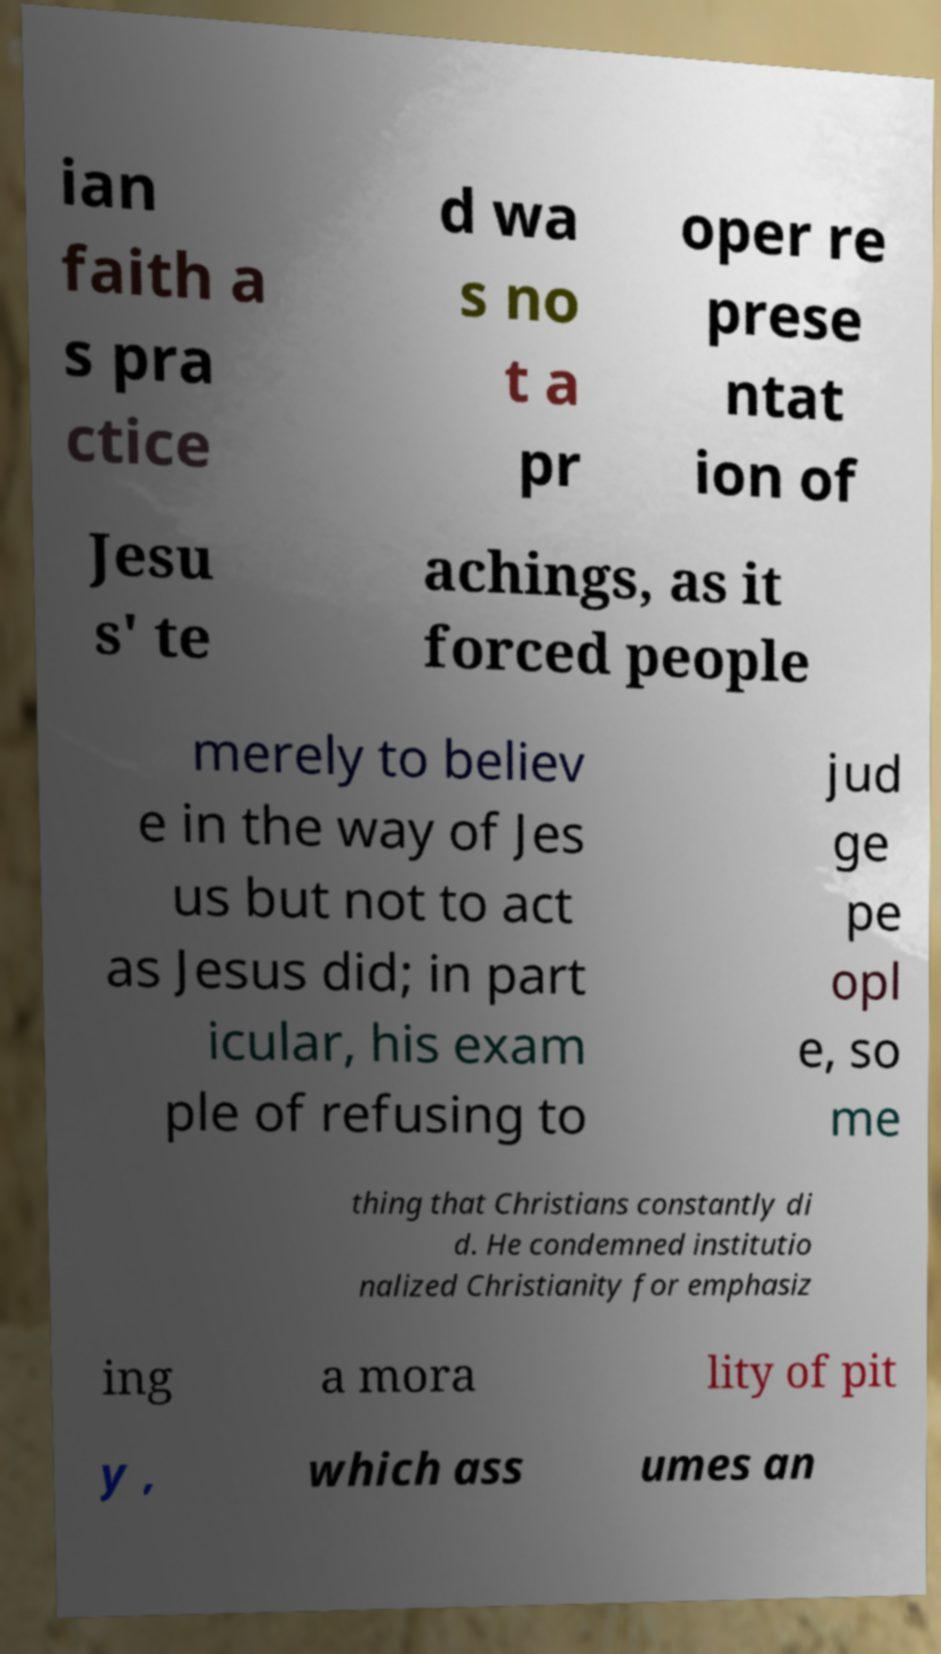Please identify and transcribe the text found in this image. ian faith a s pra ctice d wa s no t a pr oper re prese ntat ion of Jesu s' te achings, as it forced people merely to believ e in the way of Jes us but not to act as Jesus did; in part icular, his exam ple of refusing to jud ge pe opl e, so me thing that Christians constantly di d. He condemned institutio nalized Christianity for emphasiz ing a mora lity of pit y , which ass umes an 